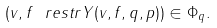Convert formula to latex. <formula><loc_0><loc_0><loc_500><loc_500>( v , f \ r e s t r Y ( v , f , q , p ) ) \in \Phi _ { q } .</formula> 